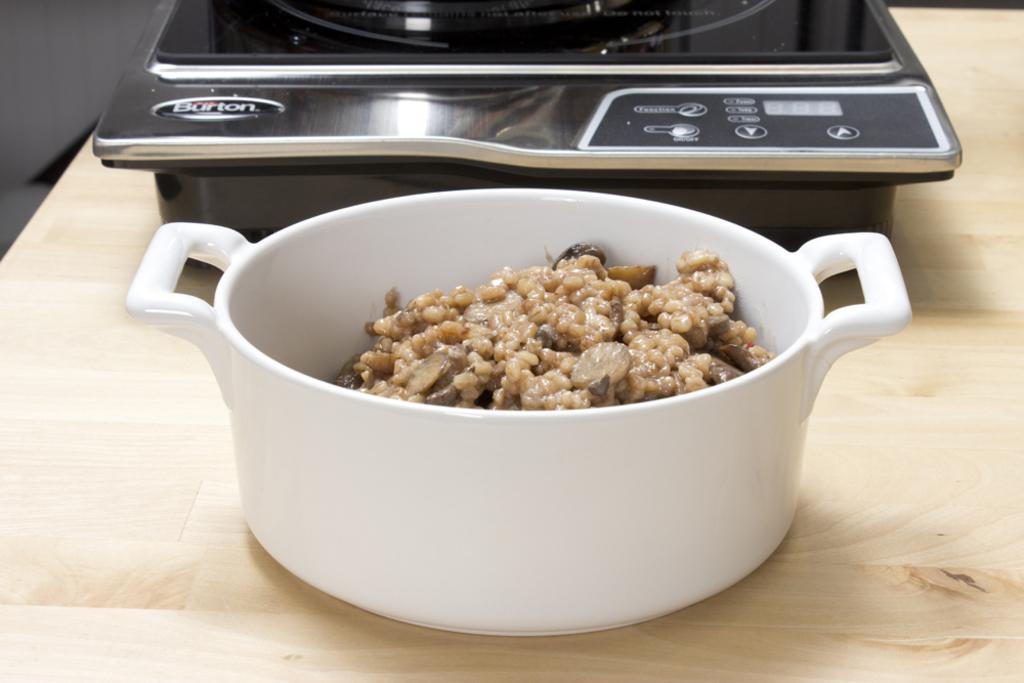<image>
Describe the image concisely. White bowl of food near a silver machine that says "Burton" on it. 